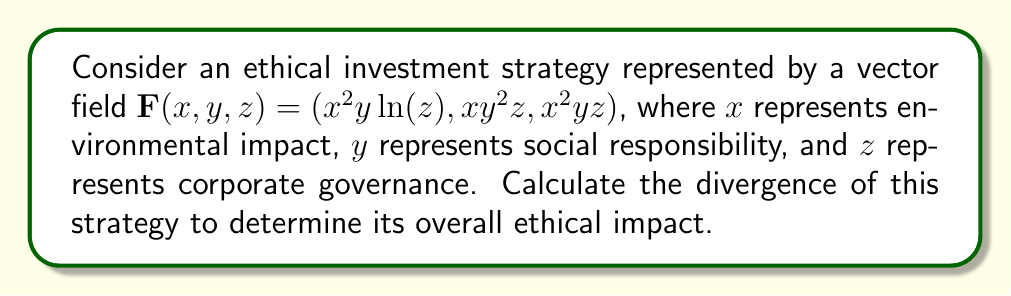Teach me how to tackle this problem. To determine the divergence of the multi-dimensional ethical investment strategy, we need to calculate the sum of the partial derivatives of each component with respect to its corresponding variable. The divergence is given by:

$$\nabla \cdot \mathbf{F} = \frac{\partial F_x}{\partial x} + \frac{\partial F_y}{\partial y} + \frac{\partial F_z}{\partial z}$$

Let's calculate each partial derivative:

1. $\frac{\partial F_x}{\partial x}$:
   $F_x = x^2y\ln(z)$
   $\frac{\partial F_x}{\partial x} = 2xy\ln(z)$

2. $\frac{\partial F_y}{\partial y}$:
   $F_y = xy^2z$
   $\frac{\partial F_y}{\partial y} = 2xyz$

3. $\frac{\partial F_z}{\partial z}$:
   $F_z = x^2yz$
   $\frac{\partial F_z}{\partial z} = x^2y$

Now, we sum these partial derivatives:

$$\nabla \cdot \mathbf{F} = 2xy\ln(z) + 2xyz + x^2y$$

This expression represents the divergence of the ethical investment strategy, indicating its overall ethical impact in terms of environmental (x), social (y), and governance (z) factors.
Answer: $2xy\ln(z) + 2xyz + x^2y$ 